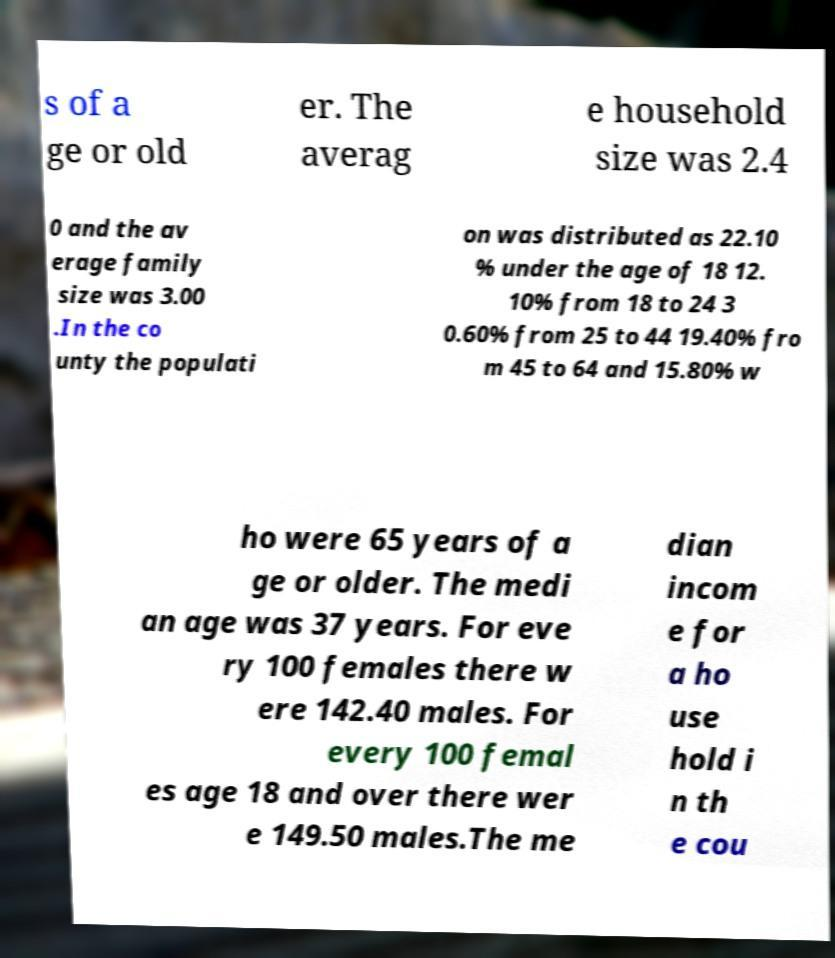I need the written content from this picture converted into text. Can you do that? s of a ge or old er. The averag e household size was 2.4 0 and the av erage family size was 3.00 .In the co unty the populati on was distributed as 22.10 % under the age of 18 12. 10% from 18 to 24 3 0.60% from 25 to 44 19.40% fro m 45 to 64 and 15.80% w ho were 65 years of a ge or older. The medi an age was 37 years. For eve ry 100 females there w ere 142.40 males. For every 100 femal es age 18 and over there wer e 149.50 males.The me dian incom e for a ho use hold i n th e cou 